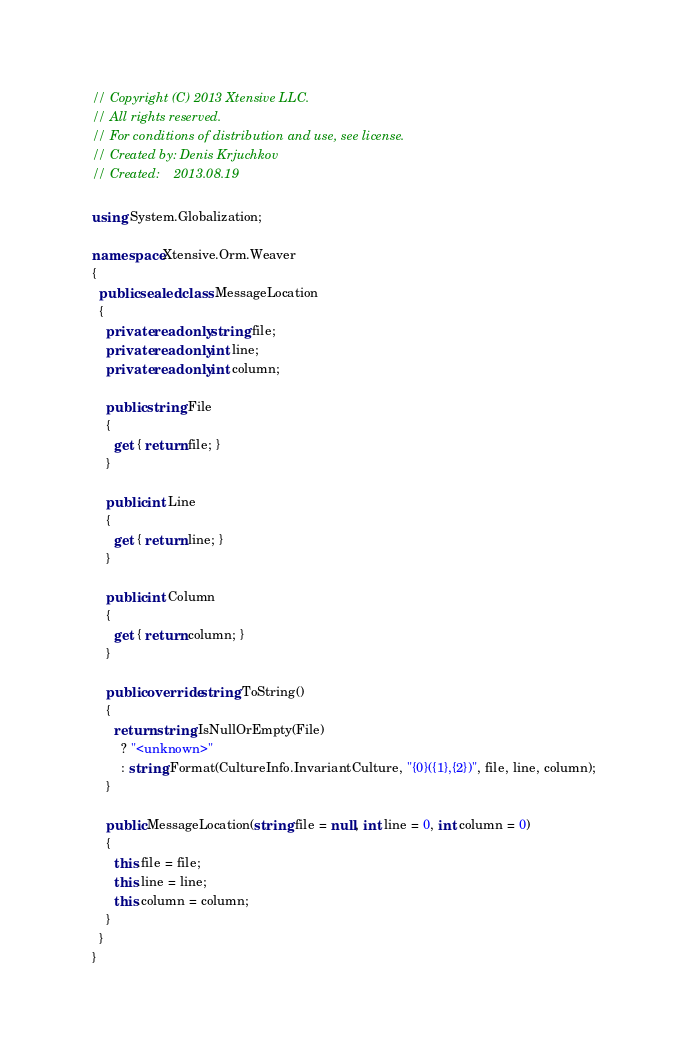Convert code to text. <code><loc_0><loc_0><loc_500><loc_500><_C#_>// Copyright (C) 2013 Xtensive LLC.
// All rights reserved.
// For conditions of distribution and use, see license.
// Created by: Denis Krjuchkov
// Created:    2013.08.19

using System.Globalization;

namespace Xtensive.Orm.Weaver
{
  public sealed class MessageLocation
  {
    private readonly string file;
    private readonly int line;
    private readonly int column;

    public string File
    {
      get { return file; }
    }

    public int Line
    {
      get { return line; }
    }

    public int Column
    {
      get { return column; }
    }

    public override string ToString()
    {
      return string.IsNullOrEmpty(File)
        ? "<unknown>"
        : string.Format(CultureInfo.InvariantCulture, "{0}({1},{2})", file, line, column);
    }

    public MessageLocation(string file = null, int line = 0, int column = 0)
    {
      this.file = file;
      this.line = line;
      this.column = column;
    }
  }
}</code> 